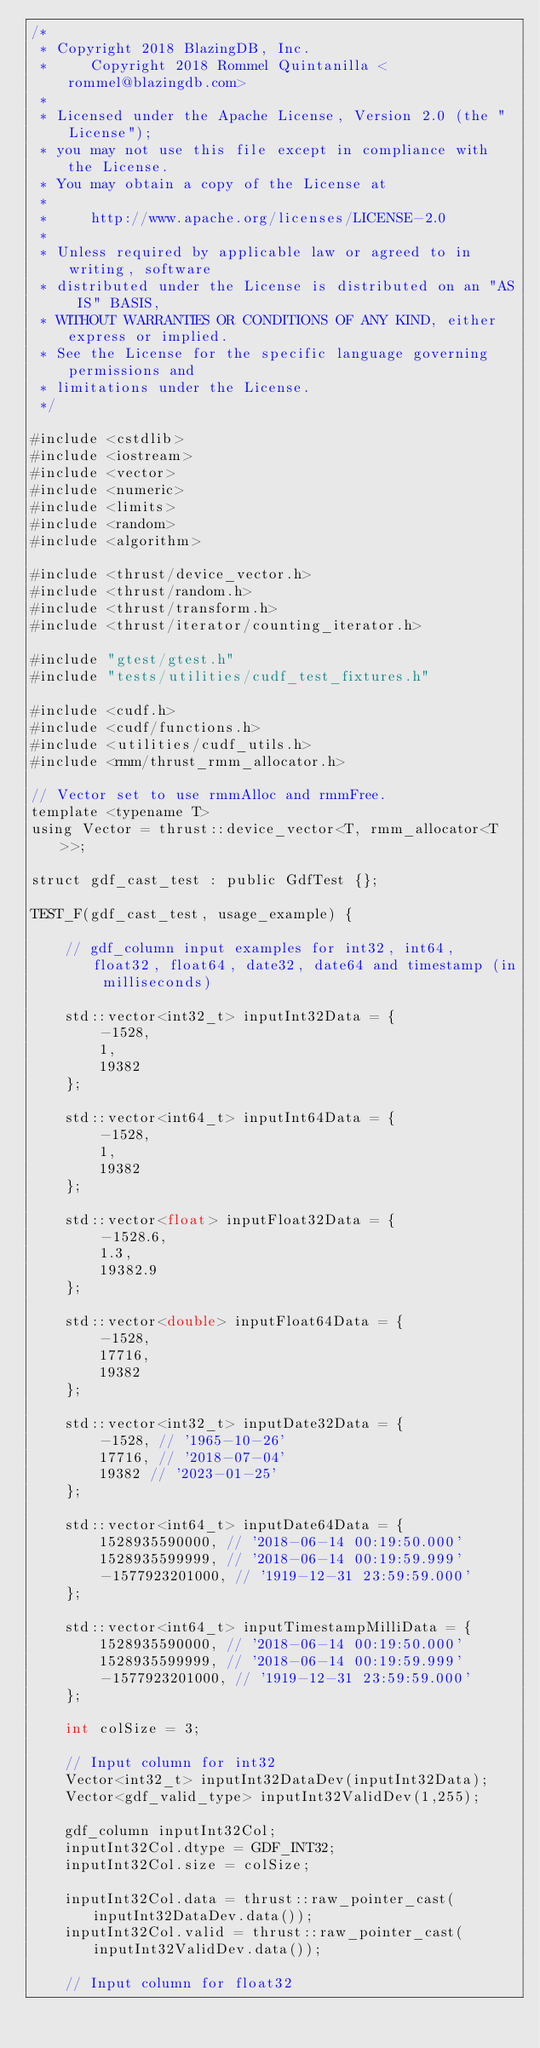<code> <loc_0><loc_0><loc_500><loc_500><_Cuda_>/*
 * Copyright 2018 BlazingDB, Inc.
 *     Copyright 2018 Rommel Quintanilla <rommel@blazingdb.com>
 *
 * Licensed under the Apache License, Version 2.0 (the "License");
 * you may not use this file except in compliance with the License.
 * You may obtain a copy of the License at
 *
 *     http://www.apache.org/licenses/LICENSE-2.0
 *
 * Unless required by applicable law or agreed to in writing, software
 * distributed under the License is distributed on an "AS IS" BASIS,
 * WITHOUT WARRANTIES OR CONDITIONS OF ANY KIND, either express or implied.
 * See the License for the specific language governing permissions and
 * limitations under the License.
 */

#include <cstdlib>
#include <iostream>
#include <vector>
#include <numeric>
#include <limits>
#include <random>
#include <algorithm>

#include <thrust/device_vector.h>
#include <thrust/random.h>
#include <thrust/transform.h>
#include <thrust/iterator/counting_iterator.h>

#include "gtest/gtest.h"
#include "tests/utilities/cudf_test_fixtures.h"

#include <cudf.h>
#include <cudf/functions.h>
#include <utilities/cudf_utils.h>
#include <rmm/thrust_rmm_allocator.h>

// Vector set to use rmmAlloc and rmmFree.
template <typename T>
using Vector = thrust::device_vector<T, rmm_allocator<T>>;

struct gdf_cast_test : public GdfTest {};

TEST_F(gdf_cast_test, usage_example) {

	// gdf_column input examples for int32, int64, float32, float64, date32, date64 and timestamp (in milliseconds)

	std::vector<int32_t> inputInt32Data = {
		-1528,
		1,
		19382
	};

	std::vector<int64_t> inputInt64Data = {
		-1528,
		1,
		19382
	};

	std::vector<float> inputFloat32Data = {
		-1528.6,
		1.3,
		19382.9
	};

	std::vector<double> inputFloat64Data = {
		-1528,
		17716,
		19382
	};

	std::vector<int32_t> inputDate32Data = {
		-1528, // '1965-10-26'
		17716, // '2018-07-04'
		19382 // '2023-01-25'
	};

	std::vector<int64_t> inputDate64Data = {
		1528935590000, // '2018-06-14 00:19:50.000'
		1528935599999, // '2018-06-14 00:19:59.999'
		-1577923201000, // '1919-12-31 23:59:59.000'
	};

	std::vector<int64_t> inputTimestampMilliData = {
		1528935590000, // '2018-06-14 00:19:50.000'
		1528935599999, // '2018-06-14 00:19:59.999'
		-1577923201000, // '1919-12-31 23:59:59.000'
	};

	int colSize = 3;

	// Input column for int32
	Vector<int32_t> inputInt32DataDev(inputInt32Data);
	Vector<gdf_valid_type> inputInt32ValidDev(1,255);

	gdf_column inputInt32Col;
	inputInt32Col.dtype = GDF_INT32;
	inputInt32Col.size = colSize;

	inputInt32Col.data = thrust::raw_pointer_cast(inputInt32DataDev.data());
	inputInt32Col.valid = thrust::raw_pointer_cast(inputInt32ValidDev.data());

	// Input column for float32</code> 